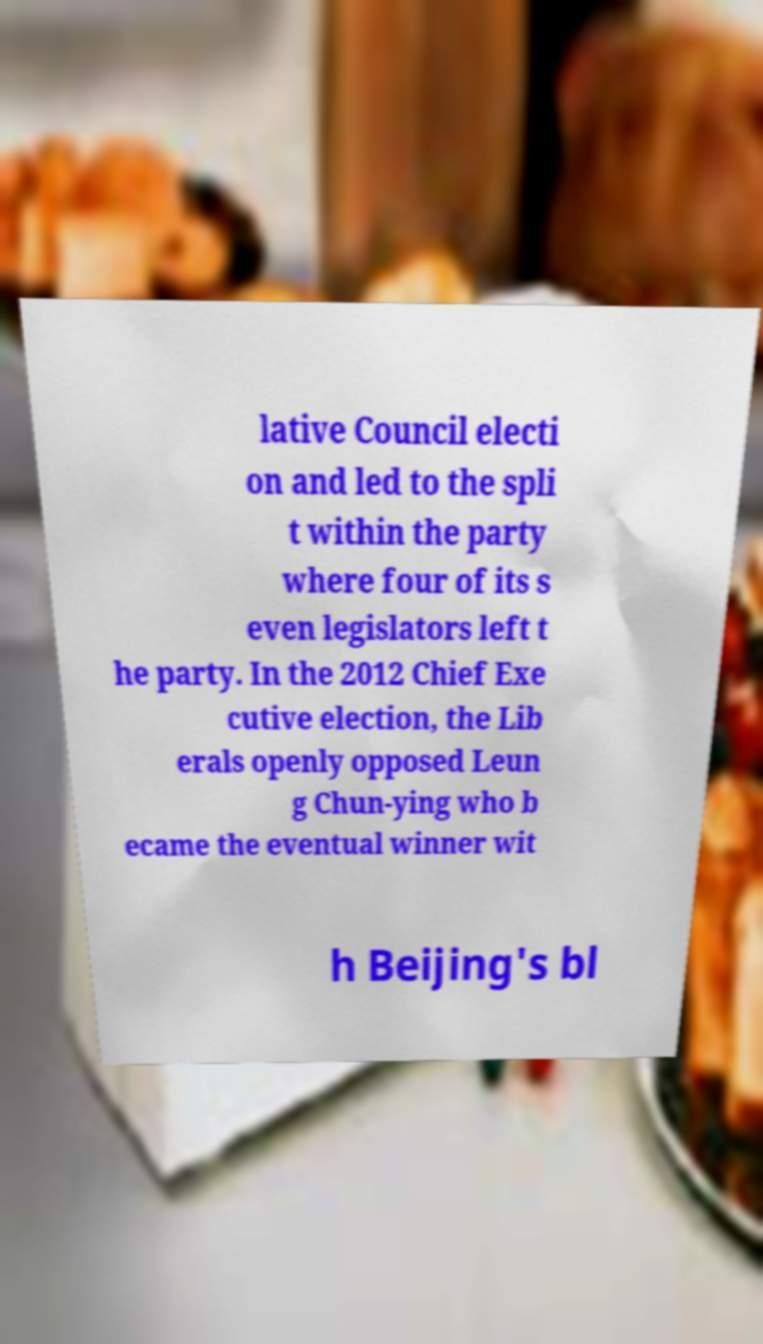Could you extract and type out the text from this image? lative Council electi on and led to the spli t within the party where four of its s even legislators left t he party. In the 2012 Chief Exe cutive election, the Lib erals openly opposed Leun g Chun-ying who b ecame the eventual winner wit h Beijing's bl 